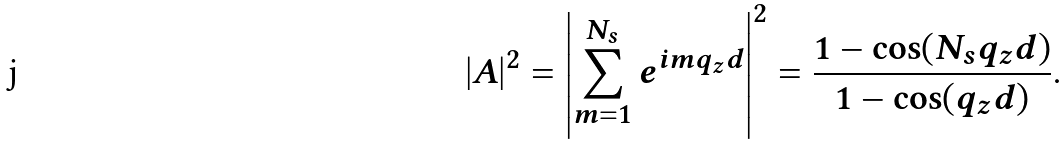Convert formula to latex. <formula><loc_0><loc_0><loc_500><loc_500>\left | A \right | ^ { 2 } = \left | \sum _ { m = 1 } ^ { N _ { s } } e ^ { i m q _ { z } d } \right | ^ { 2 } = \frac { 1 - \cos ( N _ { s } q _ { z } d ) } { 1 - \cos ( q _ { z } d ) } .</formula> 